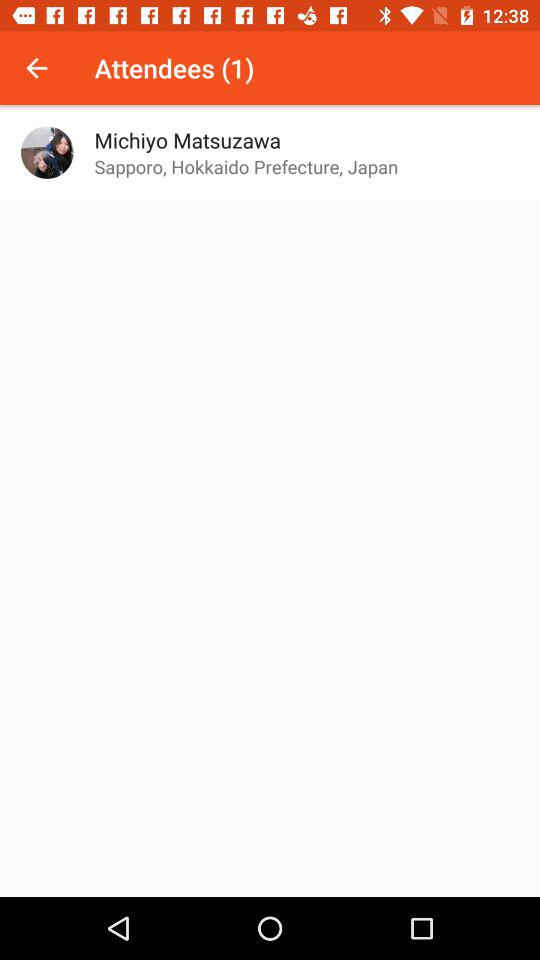What is the name of the user? The name of the user is Michiyo Matsuzawa. 